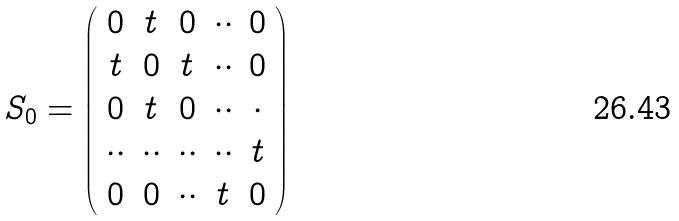<formula> <loc_0><loc_0><loc_500><loc_500>S _ { 0 } = \left ( \begin{array} { c c c c c } 0 & t & 0 & \cdot \cdot & 0 \\ t & 0 & t & \cdot \cdot & 0 \\ 0 & t & 0 & \cdot \cdot & \cdot \\ \cdot \cdot & \cdot \cdot & \cdot \cdot & \cdot \cdot & t \\ 0 & 0 & \cdot \cdot & t & 0 \end{array} \right )</formula> 